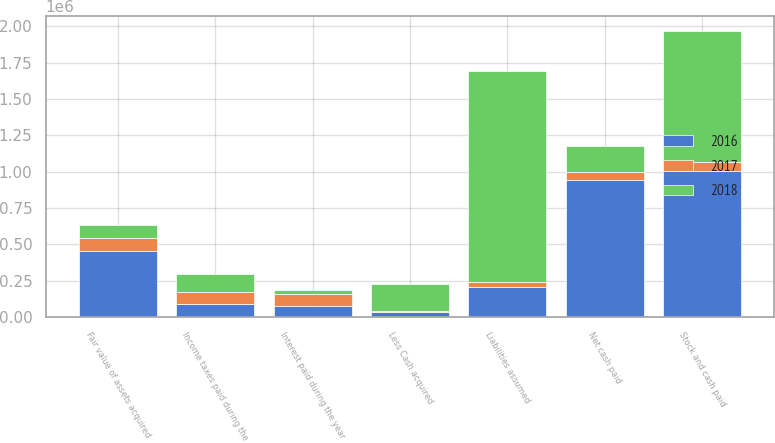<chart> <loc_0><loc_0><loc_500><loc_500><stacked_bar_chart><ecel><fcel>Interest paid during the year<fcel>Income taxes paid during the<fcel>Fair value of assets acquired<fcel>Liabilities assumed<fcel>Stock and cash paid<fcel>Less Cash acquired<fcel>Net cash paid<nl><fcel>2017<fcel>81756<fcel>83949<fcel>91758<fcel>32908<fcel>58850<fcel>7697<fcel>51153<nl><fcel>2016<fcel>75317<fcel>89379<fcel>452209<fcel>207788<fcel>1.00621e+06<fcel>35408<fcel>945299<nl><fcel>2018<fcel>30211<fcel>121563<fcel>90568.5<fcel>1.45338e+06<fcel>904695<fcel>186903<fcel>183113<nl></chart> 